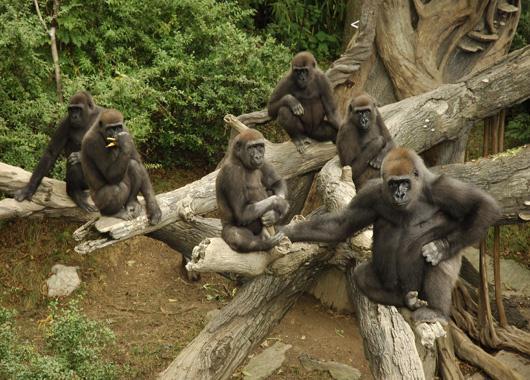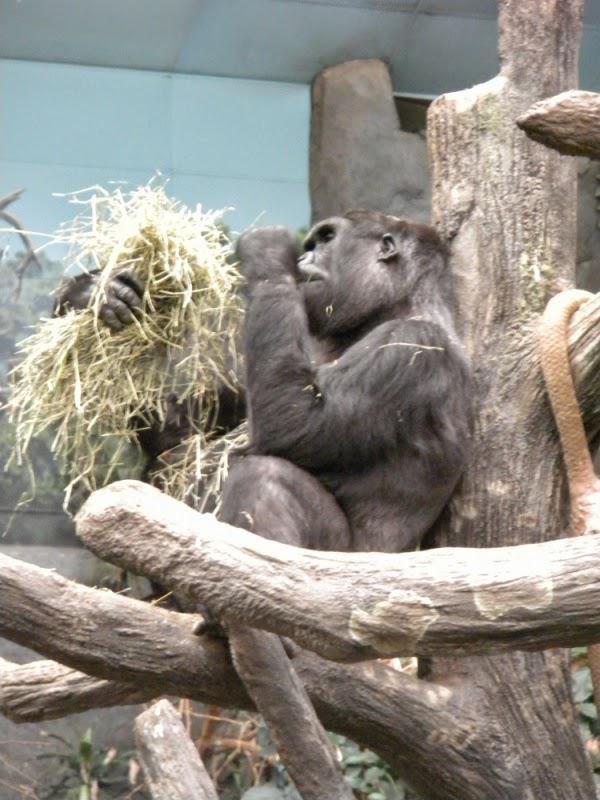The first image is the image on the left, the second image is the image on the right. Considering the images on both sides, is "One image shows multiple gorillas sitting on fallen logs in front of a massive tree trunk covered with twisted brown shapes." valid? Answer yes or no. Yes. The first image is the image on the left, the second image is the image on the right. Evaluate the accuracy of this statement regarding the images: "there are multiple gorillas sitting on logs in various sizes in front of a lasrge tree trunk". Is it true? Answer yes or no. Yes. 